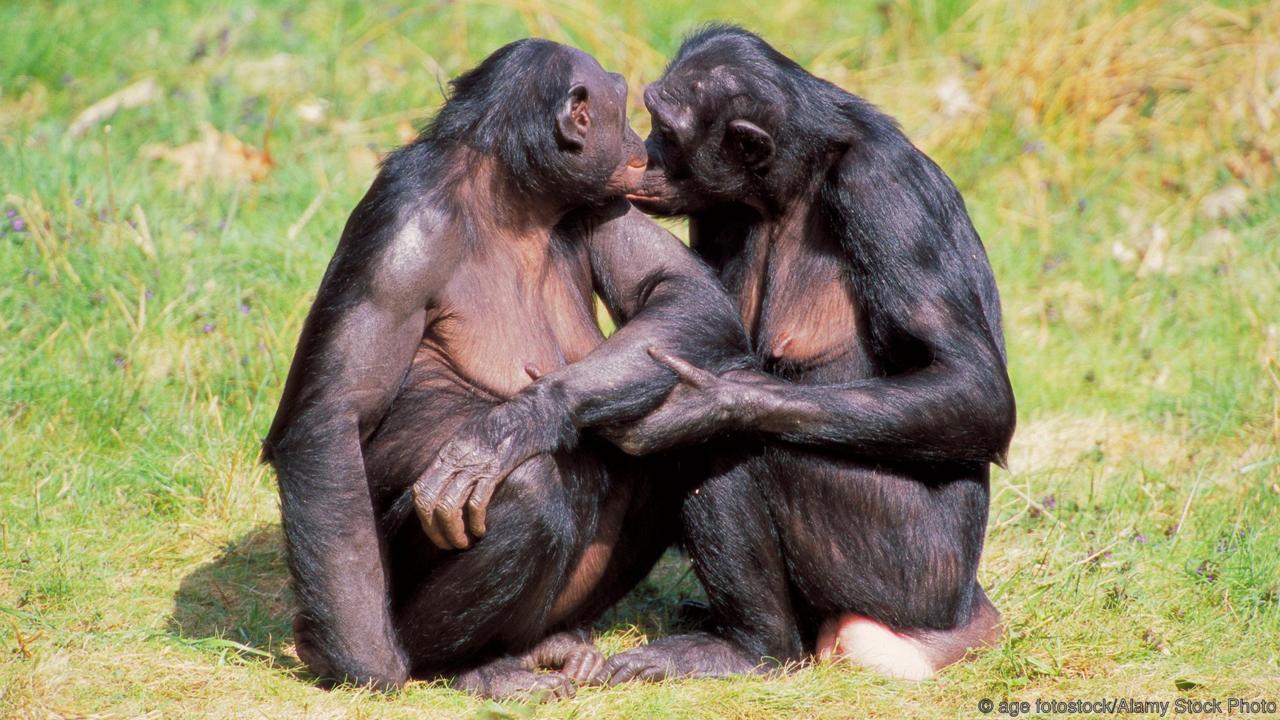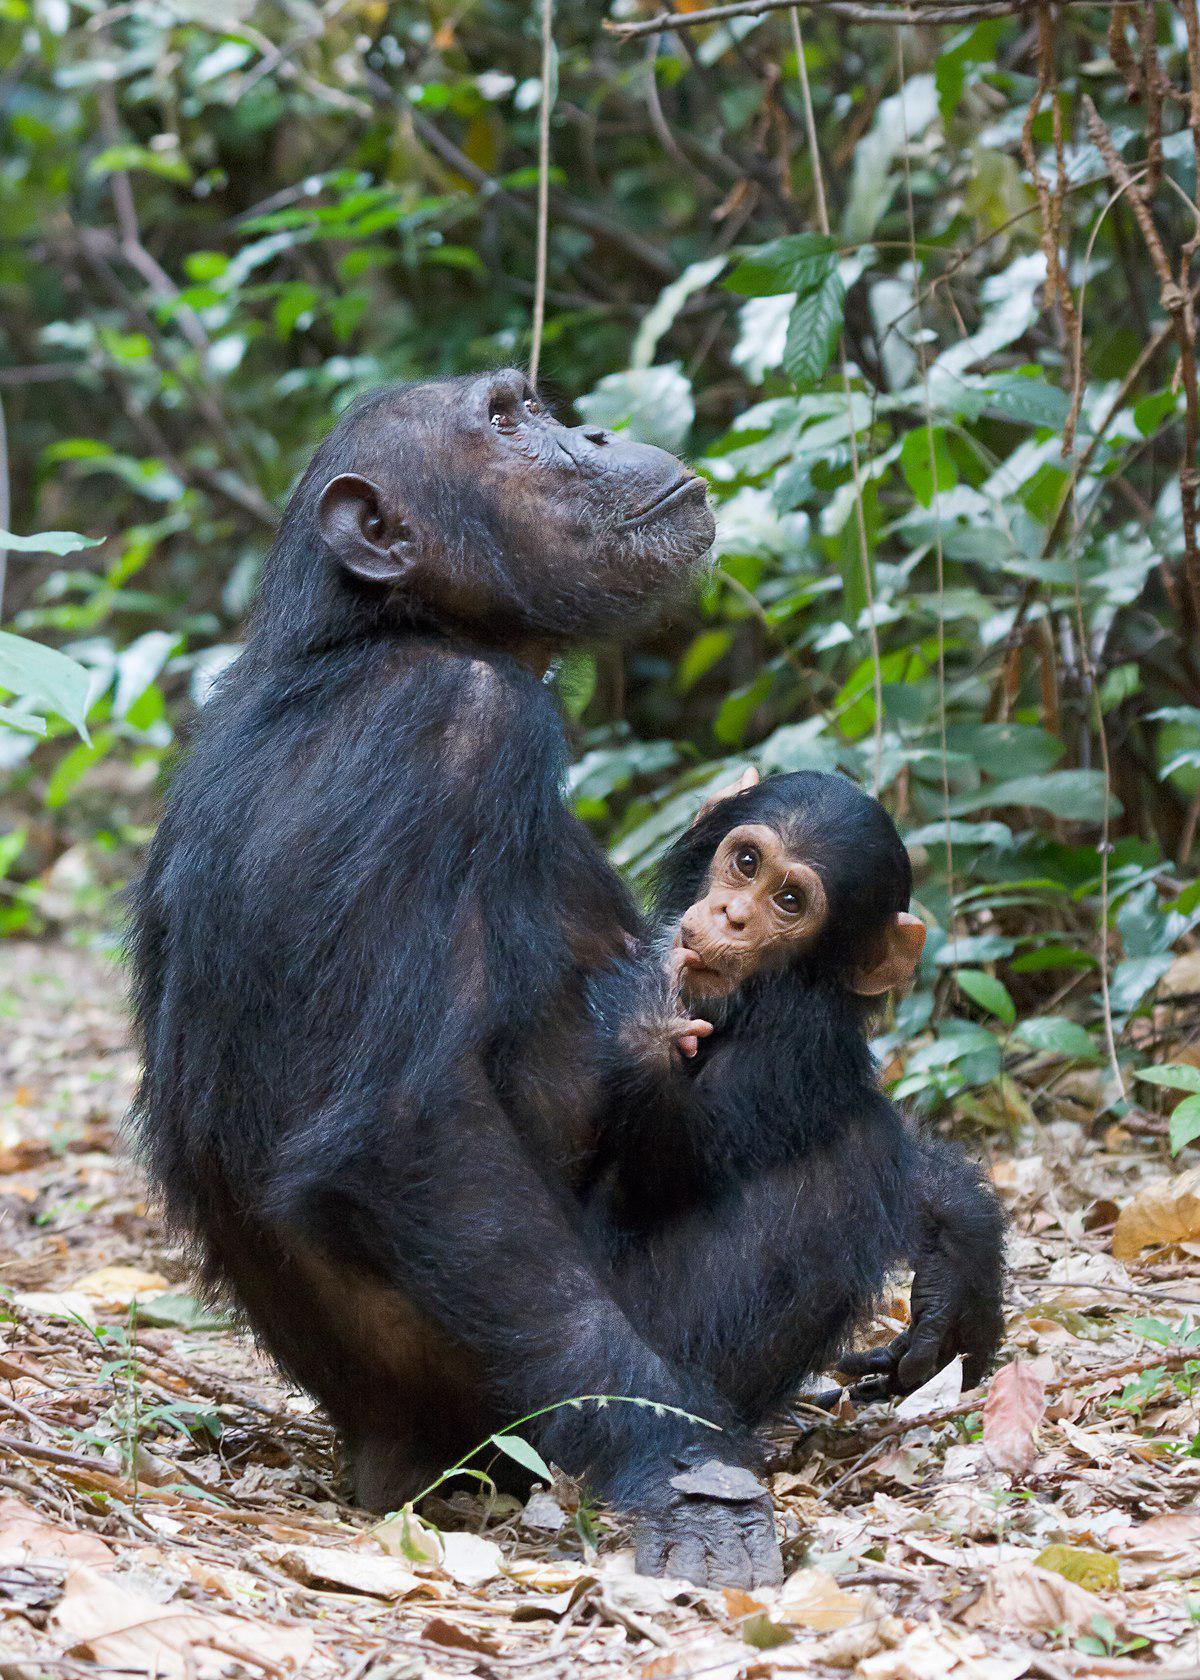The first image is the image on the left, the second image is the image on the right. Analyze the images presented: Is the assertion "The left image has at least one chimp lying down." valid? Answer yes or no. No. The first image is the image on the left, the second image is the image on the right. For the images displayed, is the sentence "A chimpanzee sleeps alone." factually correct? Answer yes or no. No. 